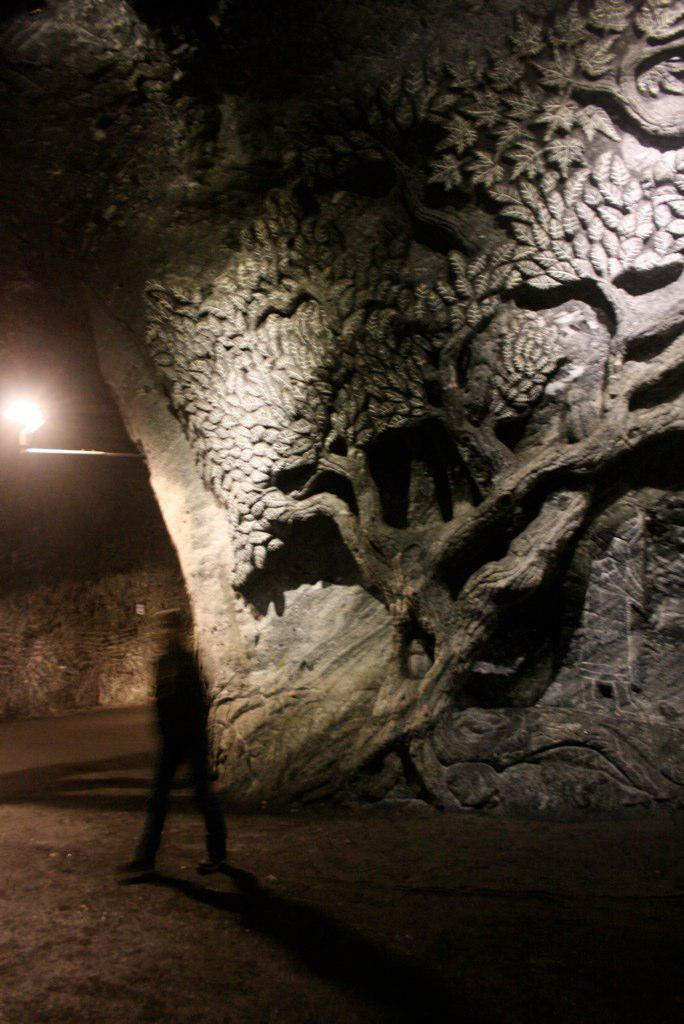What is the main action of the person in the image? The person is walking in the image. What surface is the person walking on? The person is walking on the floor. What can be seen on the right side of the image? There is a wall with a sculpture on the right side of the image. What type of lighting is present in the image? There is a lamp with a pole in the image. How does the person in the image need to sit down to continue walking? The person in the image does not need to sit down to continue walking, as walking is a standing action. 